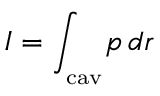Convert formula to latex. <formula><loc_0><loc_0><loc_500><loc_500>I = \int _ { _ { c } a v } \, p \, d r</formula> 